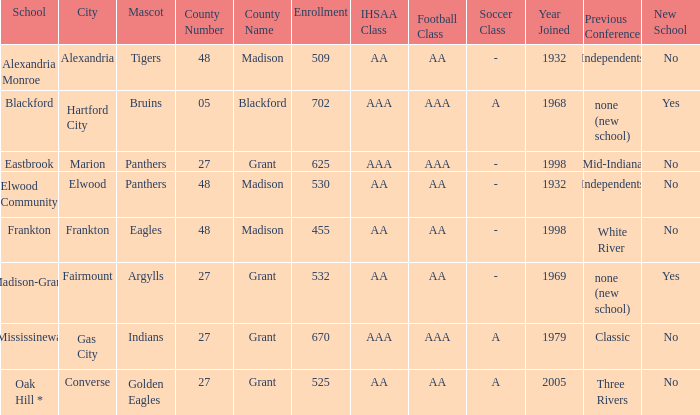What is the previous conference when the location is converse? Three Rivers. 